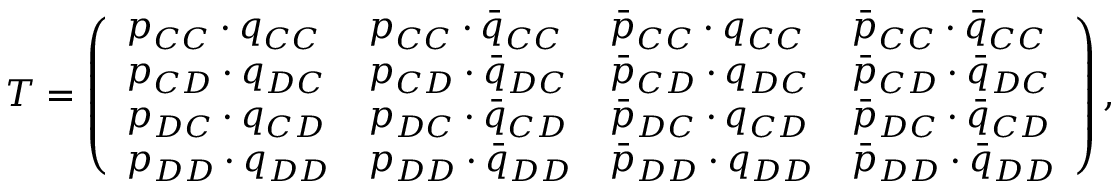<formula> <loc_0><loc_0><loc_500><loc_500>T = \left ( \begin{array} { l l l l } { p _ { C C } \cdot q _ { C C } } & { p _ { C C } \cdot \bar { q } _ { C C } } & { \bar { p } _ { C C } \cdot q _ { C C } } & { \bar { p } _ { C C } \cdot \bar { q } _ { C C } } \\ { p _ { C D } \cdot q _ { D C } } & { p _ { C D } \cdot \bar { q } _ { D C } } & { \bar { p } _ { C D } \cdot q _ { D C } } & { \bar { p } _ { C D } \cdot \bar { q } _ { D C } } \\ { p _ { D C } \cdot q _ { C D } } & { p _ { D C } \cdot \bar { q } _ { C D } } & { \bar { p } _ { D C } \cdot q _ { C D } } & { \bar { p } _ { D C } \cdot \bar { q } _ { C D } } \\ { p _ { D D } \cdot q _ { D D } } & { p _ { D D } \cdot \bar { q } _ { D D } } & { \bar { p } _ { D D } \cdot q _ { D D } } & { \bar { p } _ { D D } \cdot \bar { q } _ { D D } } \end{array} \right ) ,</formula> 